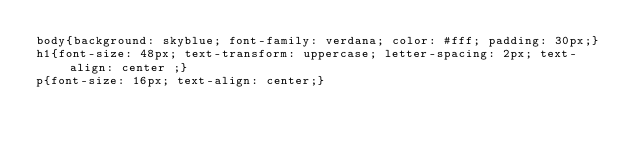<code> <loc_0><loc_0><loc_500><loc_500><_CSS_>body{background: skyblue; font-family: verdana; color: #fff; padding: 30px;}
h1{font-size: 48px; text-transform: uppercase; letter-spacing: 2px; text-align: center ;}
p{font-size: 16px; text-align: center;}</code> 